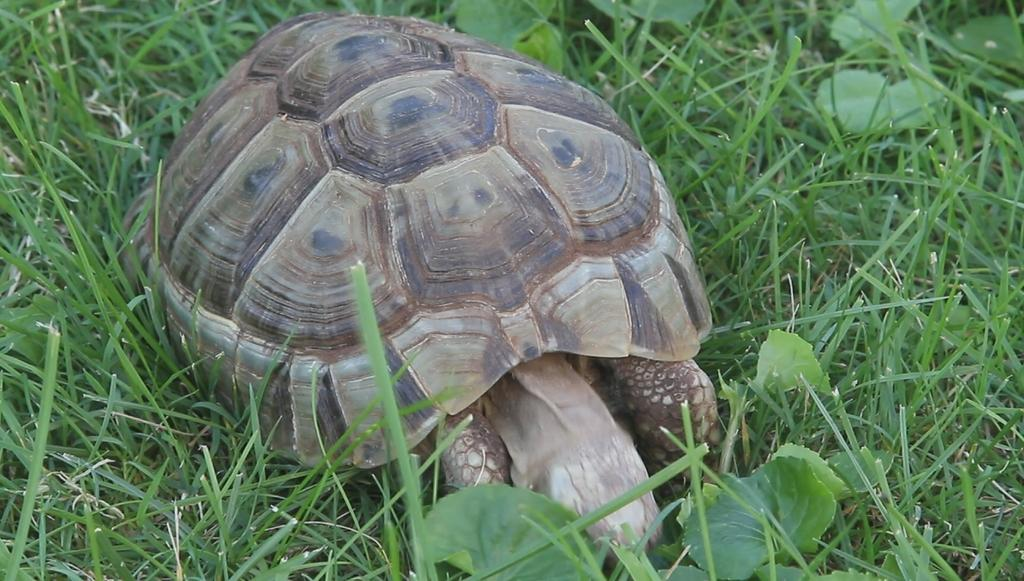What type of animal is in the image? There is a tortoise in the image. Where is the tortoise located? The tortoise is on the ground. What type of vegetation can be seen in the image? There is grass and plants visible in the image. Who is the mother of the tortoise in the image? There is no indication of a mother tortoise in the image, as tortoises are not mammals and do not have mothers in the same way as humans or other mammals. 